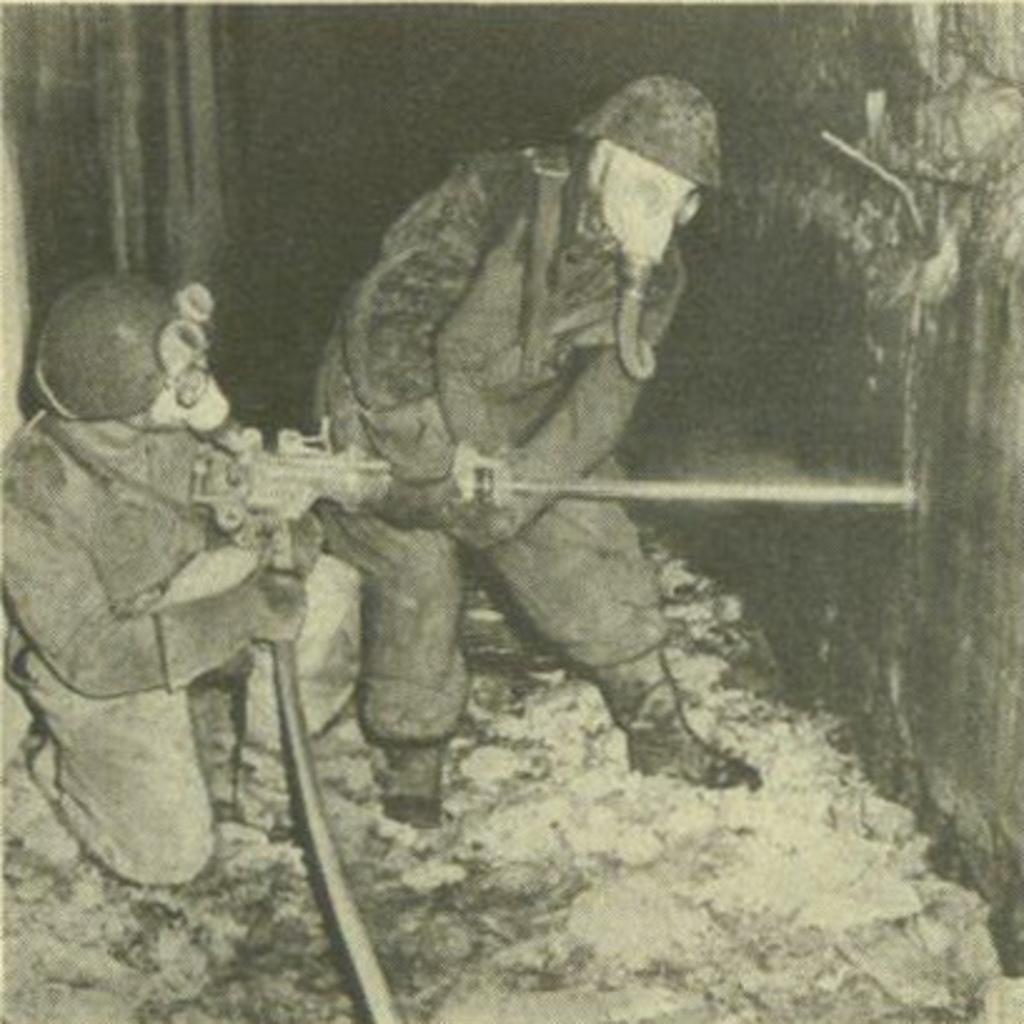How many people are in the image? There are two men in the image. What are the men holding in the image? The men are holding a machine. What are the men wearing on their faces? The men are wearing masks. What type of light can be seen emanating from the earth in the image? There is no light emanating from the earth in the image, nor is there any reference to the earth in the provided facts. 